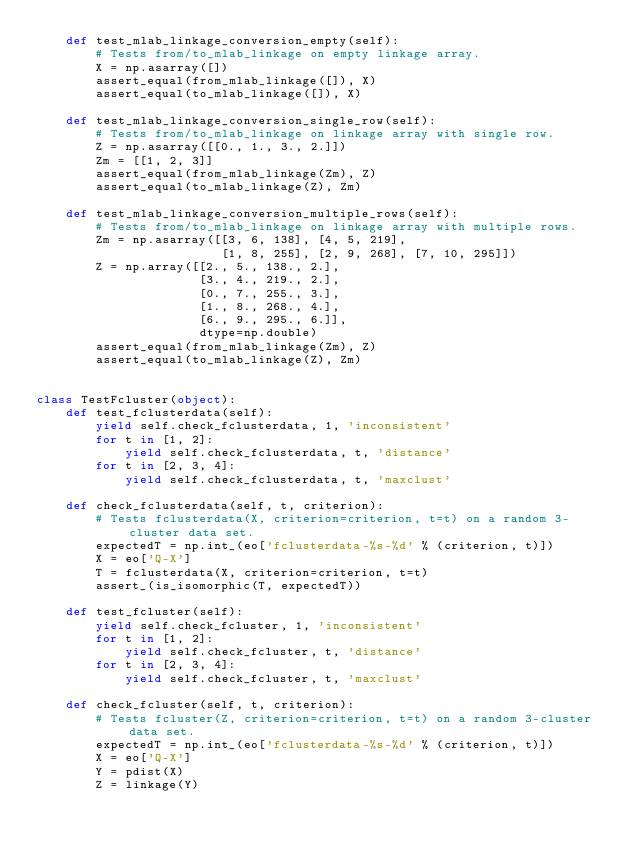<code> <loc_0><loc_0><loc_500><loc_500><_Python_>    def test_mlab_linkage_conversion_empty(self):
        # Tests from/to_mlab_linkage on empty linkage array.
        X = np.asarray([])
        assert_equal(from_mlab_linkage([]), X)
        assert_equal(to_mlab_linkage([]), X)

    def test_mlab_linkage_conversion_single_row(self):
        # Tests from/to_mlab_linkage on linkage array with single row.
        Z = np.asarray([[0., 1., 3., 2.]])
        Zm = [[1, 2, 3]]
        assert_equal(from_mlab_linkage(Zm), Z)
        assert_equal(to_mlab_linkage(Z), Zm)

    def test_mlab_linkage_conversion_multiple_rows(self):
        # Tests from/to_mlab_linkage on linkage array with multiple rows.
        Zm = np.asarray([[3, 6, 138], [4, 5, 219],
                         [1, 8, 255], [2, 9, 268], [7, 10, 295]])
        Z = np.array([[2., 5., 138., 2.],
                      [3., 4., 219., 2.],
                      [0., 7., 255., 3.],
                      [1., 8., 268., 4.],
                      [6., 9., 295., 6.]],
                      dtype=np.double)
        assert_equal(from_mlab_linkage(Zm), Z)
        assert_equal(to_mlab_linkage(Z), Zm)


class TestFcluster(object):
    def test_fclusterdata(self):
        yield self.check_fclusterdata, 1, 'inconsistent'
        for t in [1, 2]:
            yield self.check_fclusterdata, t, 'distance'
        for t in [2, 3, 4]:
            yield self.check_fclusterdata, t, 'maxclust'

    def check_fclusterdata(self, t, criterion):
        # Tests fclusterdata(X, criterion=criterion, t=t) on a random 3-cluster data set.
        expectedT = np.int_(eo['fclusterdata-%s-%d' % (criterion, t)])
        X = eo['Q-X']
        T = fclusterdata(X, criterion=criterion, t=t)
        assert_(is_isomorphic(T, expectedT))

    def test_fcluster(self):
        yield self.check_fcluster, 1, 'inconsistent'
        for t in [1, 2]:
            yield self.check_fcluster, t, 'distance'
        for t in [2, 3, 4]:
            yield self.check_fcluster, t, 'maxclust'

    def check_fcluster(self, t, criterion):
        # Tests fcluster(Z, criterion=criterion, t=t) on a random 3-cluster data set.
        expectedT = np.int_(eo['fclusterdata-%s-%d' % (criterion, t)])
        X = eo['Q-X']
        Y = pdist(X)
        Z = linkage(Y)</code> 